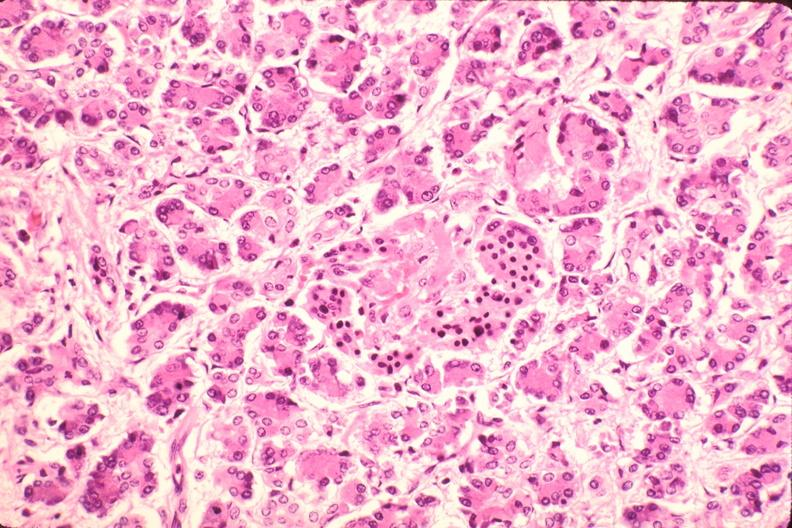what is present?
Answer the question using a single word or phrase. Endocrine 